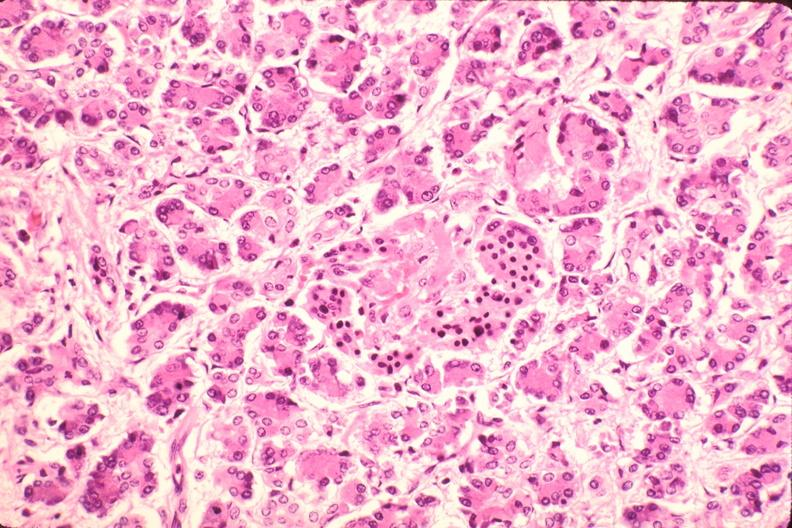what is present?
Answer the question using a single word or phrase. Endocrine 